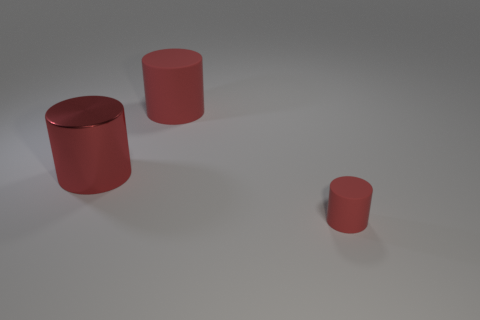There is a shiny cylinder; is it the same size as the matte thing that is right of the large red rubber cylinder?
Offer a very short reply. No. What number of objects are rubber cylinders left of the tiny red matte object or red cylinders on the right side of the big red metal thing?
Give a very brief answer. 2. What is the shape of the other object that is the same size as the metal thing?
Offer a very short reply. Cylinder. What is the shape of the big red thing that is right of the big red cylinder that is in front of the matte cylinder behind the red metallic cylinder?
Ensure brevity in your answer.  Cylinder. Are there an equal number of tiny red rubber things that are behind the big metallic object and small red rubber things?
Provide a short and direct response. No. How many matte objects are either small blocks or large cylinders?
Your answer should be compact. 1. There is a red cylinder that is the same size as the metallic object; what is its material?
Your response must be concise. Rubber. How many other things are there of the same material as the small red cylinder?
Provide a short and direct response. 1. Is the number of big cylinders in front of the red metallic cylinder less than the number of metallic things?
Your response must be concise. Yes. There is a rubber cylinder that is in front of the rubber object that is behind the rubber cylinder that is in front of the big metal thing; what is its size?
Your response must be concise. Small. 